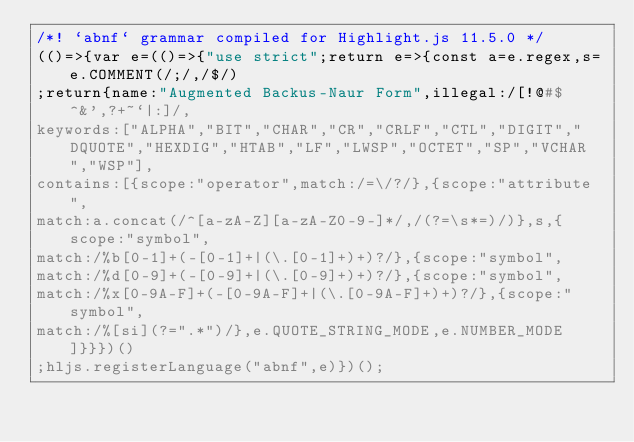Convert code to text. <code><loc_0><loc_0><loc_500><loc_500><_JavaScript_>/*! `abnf` grammar compiled for Highlight.js 11.5.0 */
(()=>{var e=(()=>{"use strict";return e=>{const a=e.regex,s=e.COMMENT(/;/,/$/)
;return{name:"Augmented Backus-Naur Form",illegal:/[!@#$^&',?+~`|:]/,
keywords:["ALPHA","BIT","CHAR","CR","CRLF","CTL","DIGIT","DQUOTE","HEXDIG","HTAB","LF","LWSP","OCTET","SP","VCHAR","WSP"],
contains:[{scope:"operator",match:/=\/?/},{scope:"attribute",
match:a.concat(/^[a-zA-Z][a-zA-Z0-9-]*/,/(?=\s*=)/)},s,{scope:"symbol",
match:/%b[0-1]+(-[0-1]+|(\.[0-1]+)+)?/},{scope:"symbol",
match:/%d[0-9]+(-[0-9]+|(\.[0-9]+)+)?/},{scope:"symbol",
match:/%x[0-9A-F]+(-[0-9A-F]+|(\.[0-9A-F]+)+)?/},{scope:"symbol",
match:/%[si](?=".*")/},e.QUOTE_STRING_MODE,e.NUMBER_MODE]}}})()
;hljs.registerLanguage("abnf",e)})();</code> 